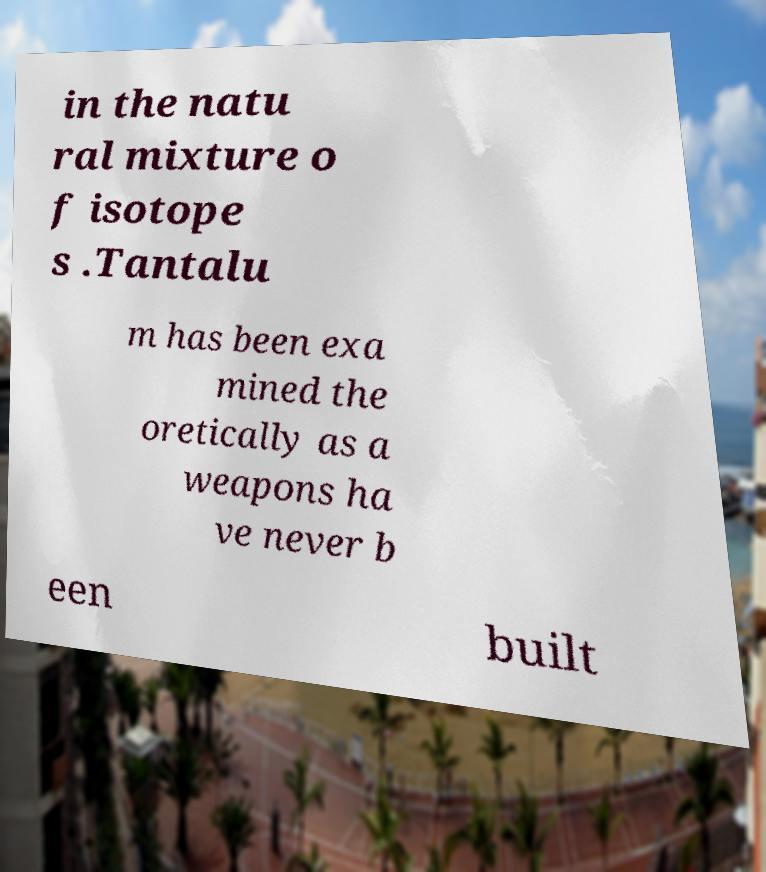Please identify and transcribe the text found in this image. in the natu ral mixture o f isotope s .Tantalu m has been exa mined the oretically as a weapons ha ve never b een built 